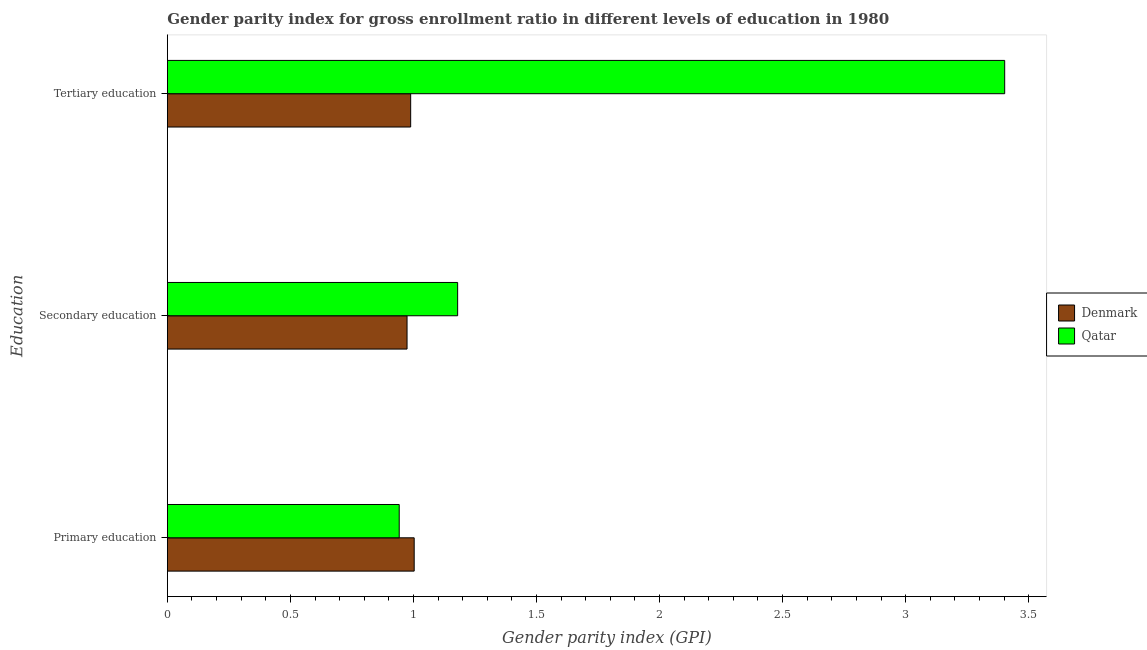How many different coloured bars are there?
Your response must be concise. 2. How many groups of bars are there?
Keep it short and to the point. 3. Are the number of bars per tick equal to the number of legend labels?
Provide a succinct answer. Yes. What is the label of the 2nd group of bars from the top?
Your response must be concise. Secondary education. What is the gender parity index in primary education in Denmark?
Your answer should be compact. 1. Across all countries, what is the maximum gender parity index in primary education?
Your answer should be very brief. 1. Across all countries, what is the minimum gender parity index in tertiary education?
Offer a very short reply. 0.99. In which country was the gender parity index in secondary education maximum?
Make the answer very short. Qatar. In which country was the gender parity index in primary education minimum?
Offer a very short reply. Qatar. What is the total gender parity index in tertiary education in the graph?
Give a very brief answer. 4.39. What is the difference between the gender parity index in primary education in Denmark and that in Qatar?
Your answer should be very brief. 0.06. What is the difference between the gender parity index in primary education in Qatar and the gender parity index in secondary education in Denmark?
Offer a terse response. -0.03. What is the average gender parity index in primary education per country?
Provide a succinct answer. 0.97. What is the difference between the gender parity index in tertiary education and gender parity index in secondary education in Denmark?
Offer a very short reply. 0.01. In how many countries, is the gender parity index in primary education greater than 3.4 ?
Provide a succinct answer. 0. What is the ratio of the gender parity index in tertiary education in Denmark to that in Qatar?
Give a very brief answer. 0.29. Is the gender parity index in tertiary education in Denmark less than that in Qatar?
Make the answer very short. Yes. What is the difference between the highest and the second highest gender parity index in secondary education?
Provide a short and direct response. 0.21. What is the difference between the highest and the lowest gender parity index in primary education?
Provide a short and direct response. 0.06. In how many countries, is the gender parity index in secondary education greater than the average gender parity index in secondary education taken over all countries?
Your response must be concise. 1. What does the 2nd bar from the top in Tertiary education represents?
Your response must be concise. Denmark. What does the 1st bar from the bottom in Secondary education represents?
Offer a very short reply. Denmark. Is it the case that in every country, the sum of the gender parity index in primary education and gender parity index in secondary education is greater than the gender parity index in tertiary education?
Keep it short and to the point. No. How many bars are there?
Ensure brevity in your answer.  6. Are all the bars in the graph horizontal?
Offer a terse response. Yes. What is the difference between two consecutive major ticks on the X-axis?
Ensure brevity in your answer.  0.5. Does the graph contain grids?
Give a very brief answer. No. How many legend labels are there?
Keep it short and to the point. 2. What is the title of the graph?
Your answer should be very brief. Gender parity index for gross enrollment ratio in different levels of education in 1980. Does "Russian Federation" appear as one of the legend labels in the graph?
Ensure brevity in your answer.  No. What is the label or title of the X-axis?
Offer a very short reply. Gender parity index (GPI). What is the label or title of the Y-axis?
Your answer should be very brief. Education. What is the Gender parity index (GPI) of Denmark in Primary education?
Your response must be concise. 1. What is the Gender parity index (GPI) of Qatar in Primary education?
Offer a terse response. 0.94. What is the Gender parity index (GPI) of Denmark in Secondary education?
Offer a terse response. 0.97. What is the Gender parity index (GPI) of Qatar in Secondary education?
Your answer should be very brief. 1.18. What is the Gender parity index (GPI) in Denmark in Tertiary education?
Ensure brevity in your answer.  0.99. What is the Gender parity index (GPI) of Qatar in Tertiary education?
Make the answer very short. 3.4. Across all Education, what is the maximum Gender parity index (GPI) of Denmark?
Offer a terse response. 1. Across all Education, what is the maximum Gender parity index (GPI) in Qatar?
Give a very brief answer. 3.4. Across all Education, what is the minimum Gender parity index (GPI) in Denmark?
Your answer should be very brief. 0.97. Across all Education, what is the minimum Gender parity index (GPI) in Qatar?
Provide a succinct answer. 0.94. What is the total Gender parity index (GPI) of Denmark in the graph?
Give a very brief answer. 2.97. What is the total Gender parity index (GPI) of Qatar in the graph?
Provide a short and direct response. 5.52. What is the difference between the Gender parity index (GPI) of Denmark in Primary education and that in Secondary education?
Offer a terse response. 0.03. What is the difference between the Gender parity index (GPI) in Qatar in Primary education and that in Secondary education?
Give a very brief answer. -0.24. What is the difference between the Gender parity index (GPI) in Denmark in Primary education and that in Tertiary education?
Ensure brevity in your answer.  0.01. What is the difference between the Gender parity index (GPI) in Qatar in Primary education and that in Tertiary education?
Ensure brevity in your answer.  -2.46. What is the difference between the Gender parity index (GPI) in Denmark in Secondary education and that in Tertiary education?
Offer a terse response. -0.01. What is the difference between the Gender parity index (GPI) of Qatar in Secondary education and that in Tertiary education?
Provide a short and direct response. -2.22. What is the difference between the Gender parity index (GPI) of Denmark in Primary education and the Gender parity index (GPI) of Qatar in Secondary education?
Offer a very short reply. -0.18. What is the difference between the Gender parity index (GPI) of Denmark in Primary education and the Gender parity index (GPI) of Qatar in Tertiary education?
Your answer should be compact. -2.4. What is the difference between the Gender parity index (GPI) in Denmark in Secondary education and the Gender parity index (GPI) in Qatar in Tertiary education?
Give a very brief answer. -2.43. What is the average Gender parity index (GPI) in Qatar per Education?
Your response must be concise. 1.84. What is the difference between the Gender parity index (GPI) of Denmark and Gender parity index (GPI) of Qatar in Primary education?
Offer a terse response. 0.06. What is the difference between the Gender parity index (GPI) of Denmark and Gender parity index (GPI) of Qatar in Secondary education?
Offer a very short reply. -0.21. What is the difference between the Gender parity index (GPI) of Denmark and Gender parity index (GPI) of Qatar in Tertiary education?
Offer a terse response. -2.41. What is the ratio of the Gender parity index (GPI) in Denmark in Primary education to that in Secondary education?
Make the answer very short. 1.03. What is the ratio of the Gender parity index (GPI) of Qatar in Primary education to that in Secondary education?
Keep it short and to the point. 0.8. What is the ratio of the Gender parity index (GPI) of Denmark in Primary education to that in Tertiary education?
Offer a very short reply. 1.01. What is the ratio of the Gender parity index (GPI) in Qatar in Primary education to that in Tertiary education?
Your response must be concise. 0.28. What is the ratio of the Gender parity index (GPI) of Denmark in Secondary education to that in Tertiary education?
Offer a terse response. 0.99. What is the ratio of the Gender parity index (GPI) of Qatar in Secondary education to that in Tertiary education?
Offer a terse response. 0.35. What is the difference between the highest and the second highest Gender parity index (GPI) of Denmark?
Your answer should be compact. 0.01. What is the difference between the highest and the second highest Gender parity index (GPI) of Qatar?
Provide a short and direct response. 2.22. What is the difference between the highest and the lowest Gender parity index (GPI) in Denmark?
Offer a terse response. 0.03. What is the difference between the highest and the lowest Gender parity index (GPI) in Qatar?
Give a very brief answer. 2.46. 